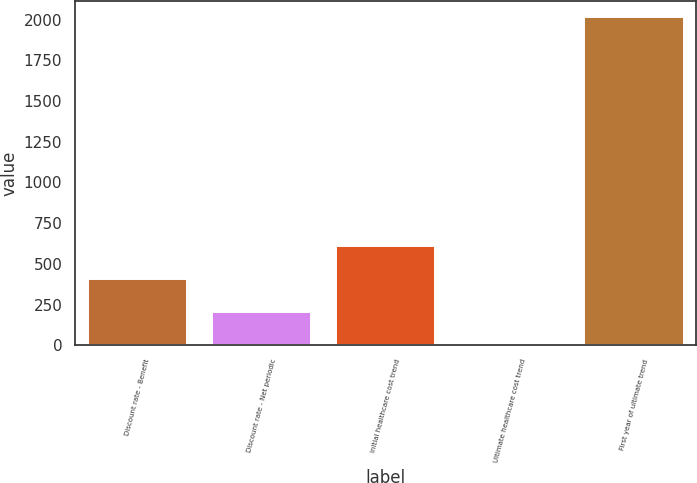Convert chart. <chart><loc_0><loc_0><loc_500><loc_500><bar_chart><fcel>Discount rate - Benefit<fcel>Discount rate - Net periodic<fcel>Initial healthcare cost trend<fcel>Ultimate healthcare cost trend<fcel>First year of ultimate trend<nl><fcel>406.8<fcel>205.9<fcel>607.7<fcel>5<fcel>2014<nl></chart> 